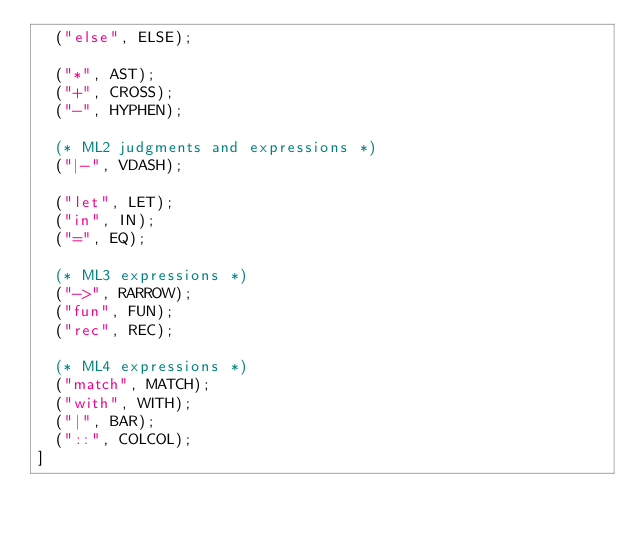<code> <loc_0><loc_0><loc_500><loc_500><_OCaml_>  ("else", ELSE);
  
  ("*", AST);
  ("+", CROSS);
  ("-", HYPHEN);

  (* ML2 judgments and expressions *)
  ("|-", VDASH);

  ("let", LET);
  ("in", IN);
  ("=", EQ);

  (* ML3 expressions *)
  ("->", RARROW);
  ("fun", FUN);
  ("rec", REC);

  (* ML4 expressions *)
  ("match", MATCH);
  ("with", WITH);
  ("|", BAR);
  ("::", COLCOL);
] 
</code> 